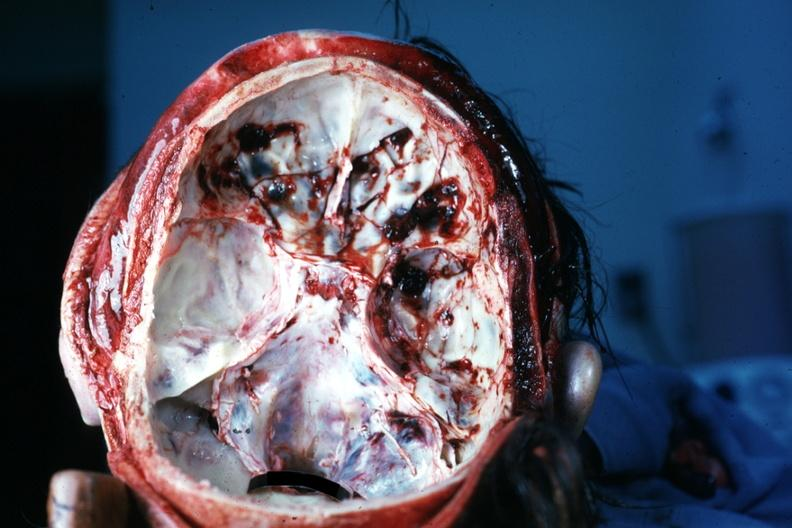s bone, calvarium present?
Answer the question using a single word or phrase. Yes 